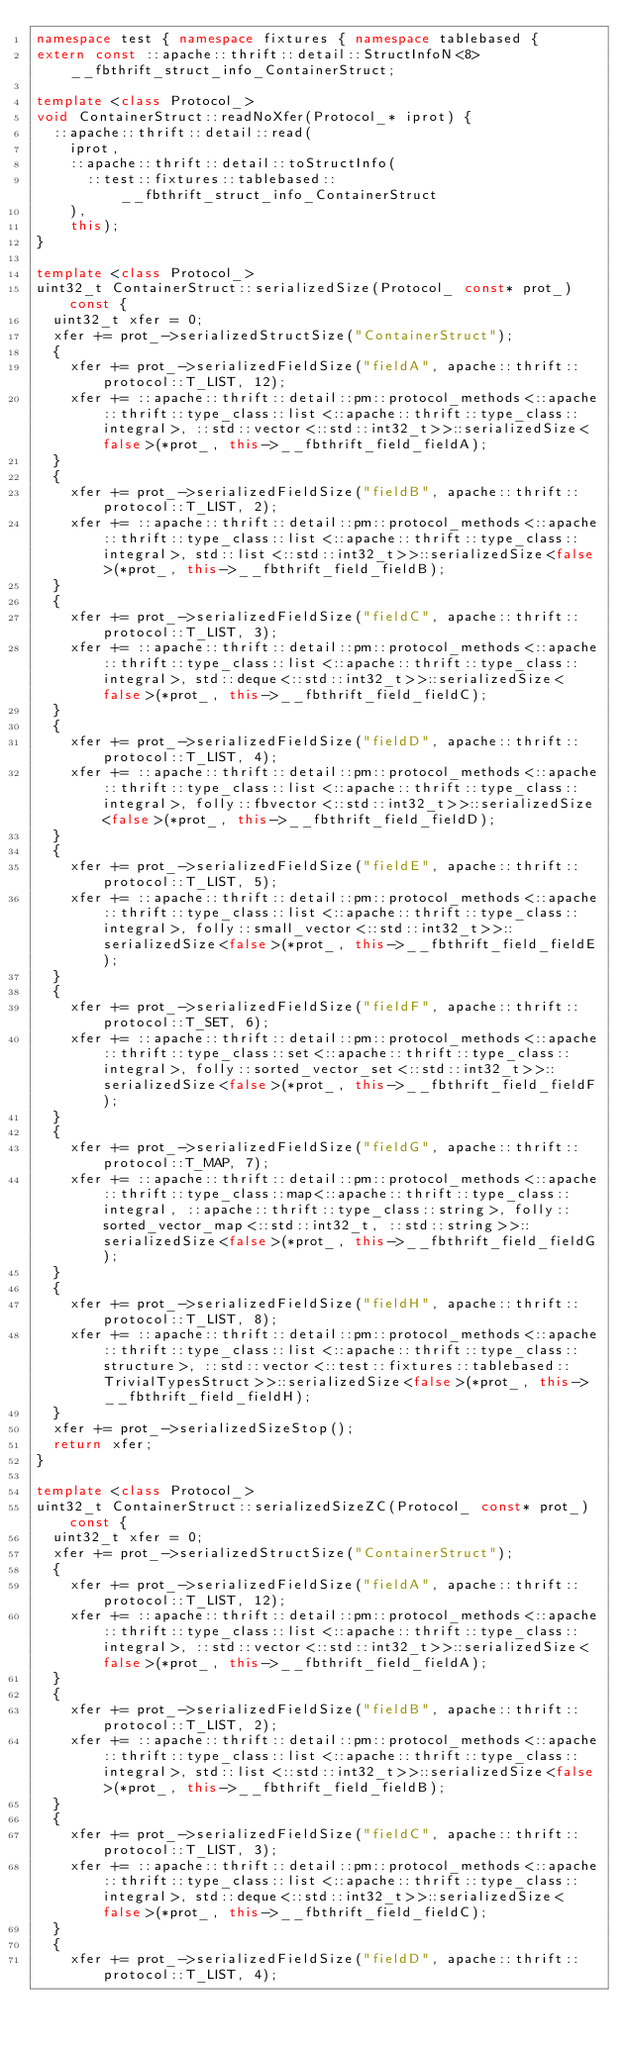Convert code to text. <code><loc_0><loc_0><loc_500><loc_500><_C++_>namespace test { namespace fixtures { namespace tablebased {
extern const ::apache::thrift::detail::StructInfoN<8> __fbthrift_struct_info_ContainerStruct;

template <class Protocol_>
void ContainerStruct::readNoXfer(Protocol_* iprot) {
  ::apache::thrift::detail::read(
    iprot,
    ::apache::thrift::detail::toStructInfo(
      ::test::fixtures::tablebased::__fbthrift_struct_info_ContainerStruct
    ),
    this);
}

template <class Protocol_>
uint32_t ContainerStruct::serializedSize(Protocol_ const* prot_) const {
  uint32_t xfer = 0;
  xfer += prot_->serializedStructSize("ContainerStruct");
  {
    xfer += prot_->serializedFieldSize("fieldA", apache::thrift::protocol::T_LIST, 12);
    xfer += ::apache::thrift::detail::pm::protocol_methods<::apache::thrift::type_class::list<::apache::thrift::type_class::integral>, ::std::vector<::std::int32_t>>::serializedSize<false>(*prot_, this->__fbthrift_field_fieldA);
  }
  {
    xfer += prot_->serializedFieldSize("fieldB", apache::thrift::protocol::T_LIST, 2);
    xfer += ::apache::thrift::detail::pm::protocol_methods<::apache::thrift::type_class::list<::apache::thrift::type_class::integral>, std::list<::std::int32_t>>::serializedSize<false>(*prot_, this->__fbthrift_field_fieldB);
  }
  {
    xfer += prot_->serializedFieldSize("fieldC", apache::thrift::protocol::T_LIST, 3);
    xfer += ::apache::thrift::detail::pm::protocol_methods<::apache::thrift::type_class::list<::apache::thrift::type_class::integral>, std::deque<::std::int32_t>>::serializedSize<false>(*prot_, this->__fbthrift_field_fieldC);
  }
  {
    xfer += prot_->serializedFieldSize("fieldD", apache::thrift::protocol::T_LIST, 4);
    xfer += ::apache::thrift::detail::pm::protocol_methods<::apache::thrift::type_class::list<::apache::thrift::type_class::integral>, folly::fbvector<::std::int32_t>>::serializedSize<false>(*prot_, this->__fbthrift_field_fieldD);
  }
  {
    xfer += prot_->serializedFieldSize("fieldE", apache::thrift::protocol::T_LIST, 5);
    xfer += ::apache::thrift::detail::pm::protocol_methods<::apache::thrift::type_class::list<::apache::thrift::type_class::integral>, folly::small_vector<::std::int32_t>>::serializedSize<false>(*prot_, this->__fbthrift_field_fieldE);
  }
  {
    xfer += prot_->serializedFieldSize("fieldF", apache::thrift::protocol::T_SET, 6);
    xfer += ::apache::thrift::detail::pm::protocol_methods<::apache::thrift::type_class::set<::apache::thrift::type_class::integral>, folly::sorted_vector_set<::std::int32_t>>::serializedSize<false>(*prot_, this->__fbthrift_field_fieldF);
  }
  {
    xfer += prot_->serializedFieldSize("fieldG", apache::thrift::protocol::T_MAP, 7);
    xfer += ::apache::thrift::detail::pm::protocol_methods<::apache::thrift::type_class::map<::apache::thrift::type_class::integral, ::apache::thrift::type_class::string>, folly::sorted_vector_map<::std::int32_t, ::std::string>>::serializedSize<false>(*prot_, this->__fbthrift_field_fieldG);
  }
  {
    xfer += prot_->serializedFieldSize("fieldH", apache::thrift::protocol::T_LIST, 8);
    xfer += ::apache::thrift::detail::pm::protocol_methods<::apache::thrift::type_class::list<::apache::thrift::type_class::structure>, ::std::vector<::test::fixtures::tablebased::TrivialTypesStruct>>::serializedSize<false>(*prot_, this->__fbthrift_field_fieldH);
  }
  xfer += prot_->serializedSizeStop();
  return xfer;
}

template <class Protocol_>
uint32_t ContainerStruct::serializedSizeZC(Protocol_ const* prot_) const {
  uint32_t xfer = 0;
  xfer += prot_->serializedStructSize("ContainerStruct");
  {
    xfer += prot_->serializedFieldSize("fieldA", apache::thrift::protocol::T_LIST, 12);
    xfer += ::apache::thrift::detail::pm::protocol_methods<::apache::thrift::type_class::list<::apache::thrift::type_class::integral>, ::std::vector<::std::int32_t>>::serializedSize<false>(*prot_, this->__fbthrift_field_fieldA);
  }
  {
    xfer += prot_->serializedFieldSize("fieldB", apache::thrift::protocol::T_LIST, 2);
    xfer += ::apache::thrift::detail::pm::protocol_methods<::apache::thrift::type_class::list<::apache::thrift::type_class::integral>, std::list<::std::int32_t>>::serializedSize<false>(*prot_, this->__fbthrift_field_fieldB);
  }
  {
    xfer += prot_->serializedFieldSize("fieldC", apache::thrift::protocol::T_LIST, 3);
    xfer += ::apache::thrift::detail::pm::protocol_methods<::apache::thrift::type_class::list<::apache::thrift::type_class::integral>, std::deque<::std::int32_t>>::serializedSize<false>(*prot_, this->__fbthrift_field_fieldC);
  }
  {
    xfer += prot_->serializedFieldSize("fieldD", apache::thrift::protocol::T_LIST, 4);</code> 